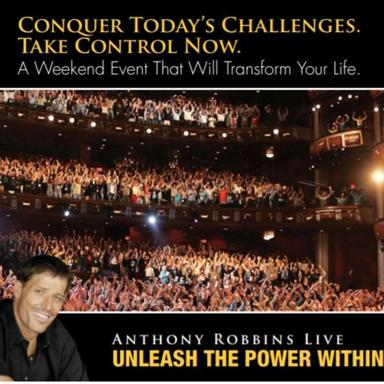Who is the main speaker at this weekend event? The main speaker featured at the 'Unleash the Power Within' event is Tony Robbins, a renowned motivational speaker and author known for his dynamic public speaking and personal development seminars. 